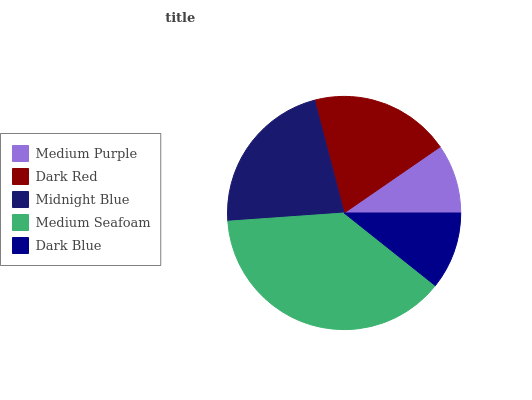Is Medium Purple the minimum?
Answer yes or no. Yes. Is Medium Seafoam the maximum?
Answer yes or no. Yes. Is Dark Red the minimum?
Answer yes or no. No. Is Dark Red the maximum?
Answer yes or no. No. Is Dark Red greater than Medium Purple?
Answer yes or no. Yes. Is Medium Purple less than Dark Red?
Answer yes or no. Yes. Is Medium Purple greater than Dark Red?
Answer yes or no. No. Is Dark Red less than Medium Purple?
Answer yes or no. No. Is Dark Red the high median?
Answer yes or no. Yes. Is Dark Red the low median?
Answer yes or no. Yes. Is Medium Seafoam the high median?
Answer yes or no. No. Is Medium Seafoam the low median?
Answer yes or no. No. 